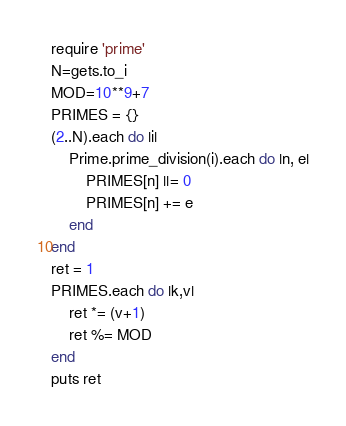Convert code to text. <code><loc_0><loc_0><loc_500><loc_500><_Ruby_>require 'prime'
N=gets.to_i
MOD=10**9+7
PRIMES = {}
(2..N).each do |i|
    Prime.prime_division(i).each do |n, e|
        PRIMES[n] ||= 0
        PRIMES[n] += e
    end
end
ret = 1
PRIMES.each do |k,v|
    ret *= (v+1)
    ret %= MOD
end
puts ret
</code> 